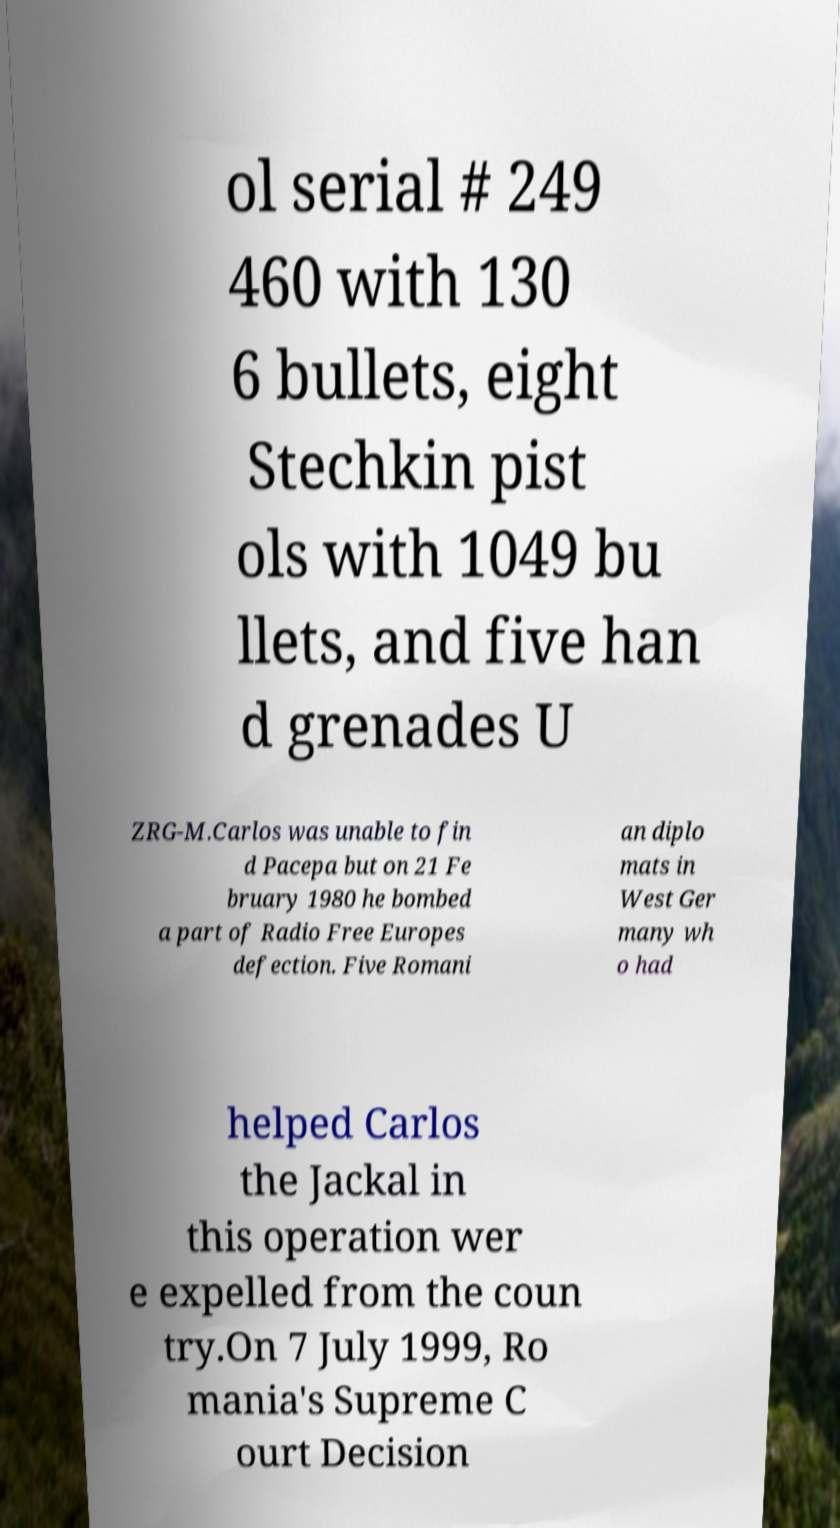For documentation purposes, I need the text within this image transcribed. Could you provide that? ol serial # 249 460 with 130 6 bullets, eight Stechkin pist ols with 1049 bu llets, and five han d grenades U ZRG-M.Carlos was unable to fin d Pacepa but on 21 Fe bruary 1980 he bombed a part of Radio Free Europes defection. Five Romani an diplo mats in West Ger many wh o had helped Carlos the Jackal in this operation wer e expelled from the coun try.On 7 July 1999, Ro mania's Supreme C ourt Decision 